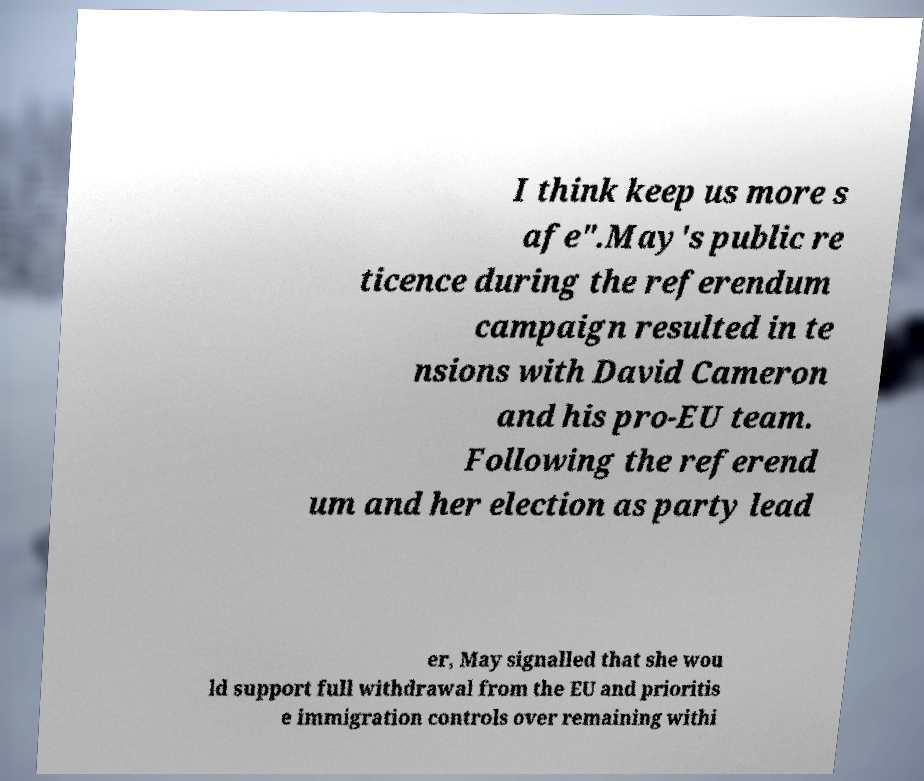I need the written content from this picture converted into text. Can you do that? I think keep us more s afe".May's public re ticence during the referendum campaign resulted in te nsions with David Cameron and his pro-EU team. Following the referend um and her election as party lead er, May signalled that she wou ld support full withdrawal from the EU and prioritis e immigration controls over remaining withi 